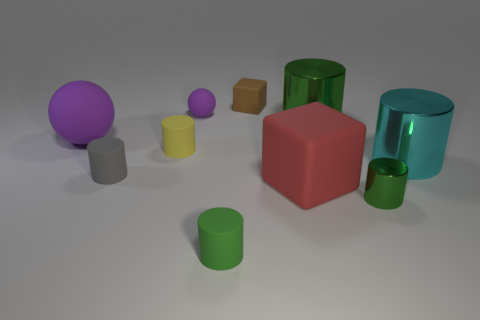Are there any other things that have the same color as the tiny metallic thing?
Make the answer very short. Yes. What material is the large green thing that is the same shape as the yellow object?
Your answer should be very brief. Metal. What number of other objects are the same size as the yellow object?
Provide a succinct answer. 5. What material is the small brown object?
Ensure brevity in your answer.  Rubber. Is the number of green metallic cylinders in front of the cyan metal cylinder greater than the number of large cyan metal balls?
Give a very brief answer. Yes. Are there any green cylinders?
Make the answer very short. Yes. How many other objects are there of the same shape as the green matte object?
Your response must be concise. 5. Is the color of the big rubber object in front of the small yellow cylinder the same as the matte block that is left of the red block?
Keep it short and to the point. No. There is a brown block on the right side of the small rubber cylinder that is in front of the large rubber thing that is in front of the large ball; what size is it?
Provide a short and direct response. Small. What shape is the large object that is behind the big matte cube and in front of the big sphere?
Keep it short and to the point. Cylinder. 